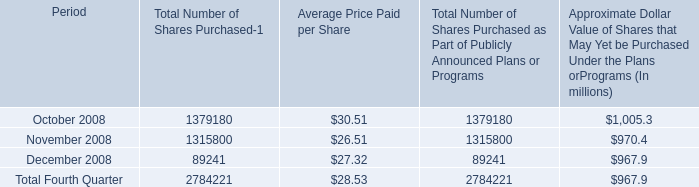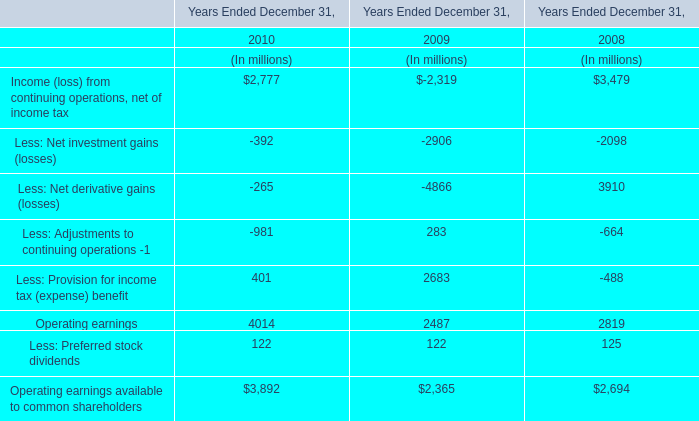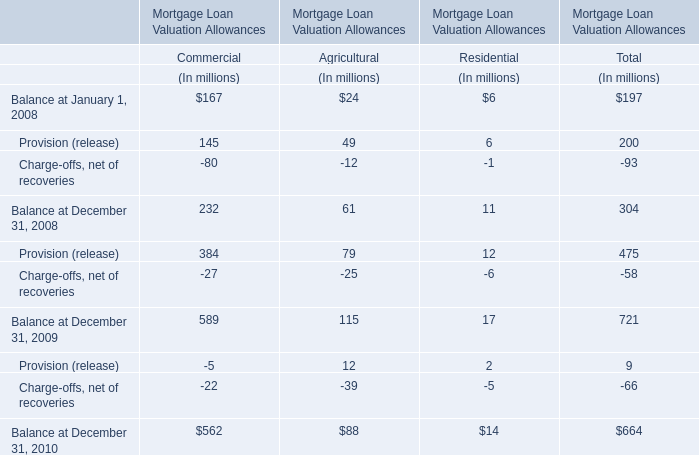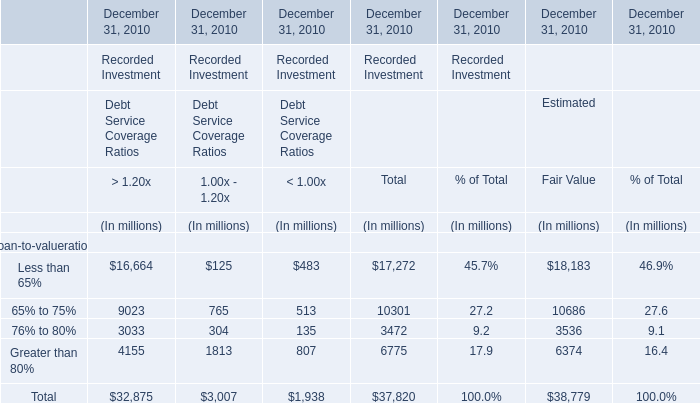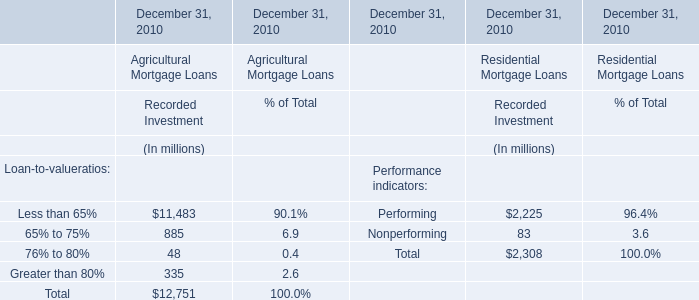What's the sum of all elements that are positive in Estimated? (in million) 
Computations: (((18183 + 10686) + 3536) + 6374)
Answer: 38779.0. 